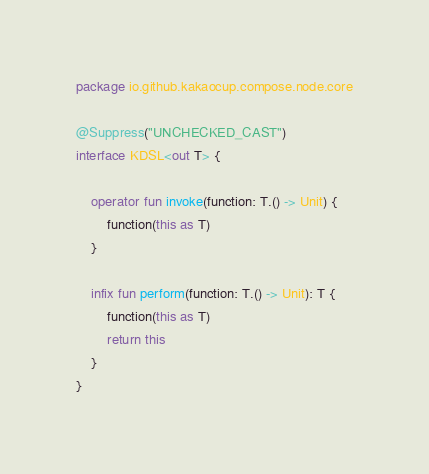Convert code to text. <code><loc_0><loc_0><loc_500><loc_500><_Kotlin_>package io.github.kakaocup.compose.node.core

@Suppress("UNCHECKED_CAST")
interface KDSL<out T> {

    operator fun invoke(function: T.() -> Unit) {
        function(this as T)
    }

    infix fun perform(function: T.() -> Unit): T {
        function(this as T)
        return this
    }
}</code> 